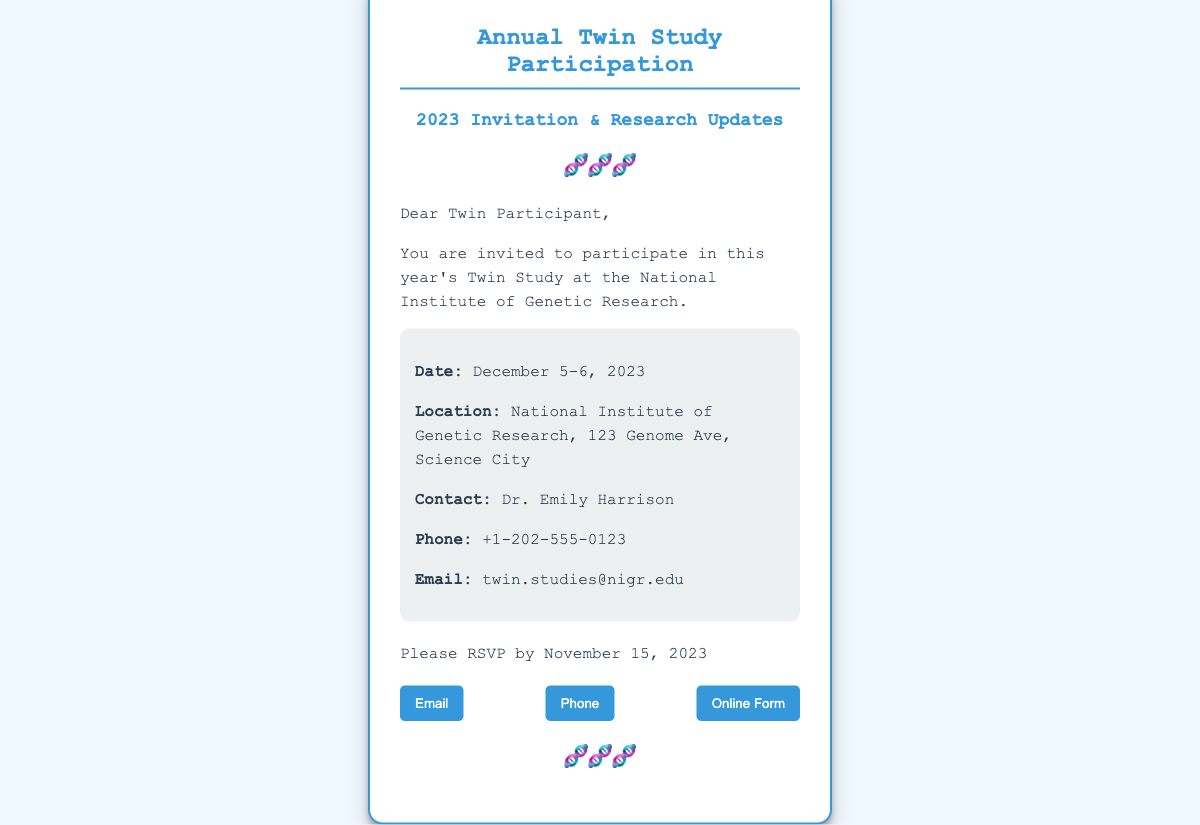What is the date of the event? The date of the Twin Study event is mentioned as December 5-6, 2023.
Answer: December 5-6, 2023 Who is the contact person? The contact person listed in the document is Dr. Emily Harrison.
Answer: Dr. Emily Harrison What is the email for RSVPs? The email address provided for RSVPs is twin.studies@nigr.edu.
Answer: twin.studies@nigr.edu What is the phone number to contact? The phone number given for contact is +1-202-555-0123.
Answer: +1-202-555-0123 By when should participants RSVP? The RSVP deadline specified in the document is November 15, 2023.
Answer: November 15, 2023 What is the location of the event? The document lists the location of the Twin Study as National Institute of Genetic Research, 123 Genome Ave, Science City.
Answer: National Institute of Genetic Research, 123 Genome Ave, Science City How many days is the Twin Study scheduled for? The duration of the Twin Study event is two days, as it occurs on December 5 and 6.
Answer: Two days What is the primary theme of the event? The primary theme of the event is participation in a Twin Study and research updates, focusing on twins.
Answer: Twin Study Participation and Research Updates What type of contact methods are provided for RSVPs? The document lists three methods for RSVPs: Email, Phone, and Online Form.
Answer: Email, Phone, Online Form 